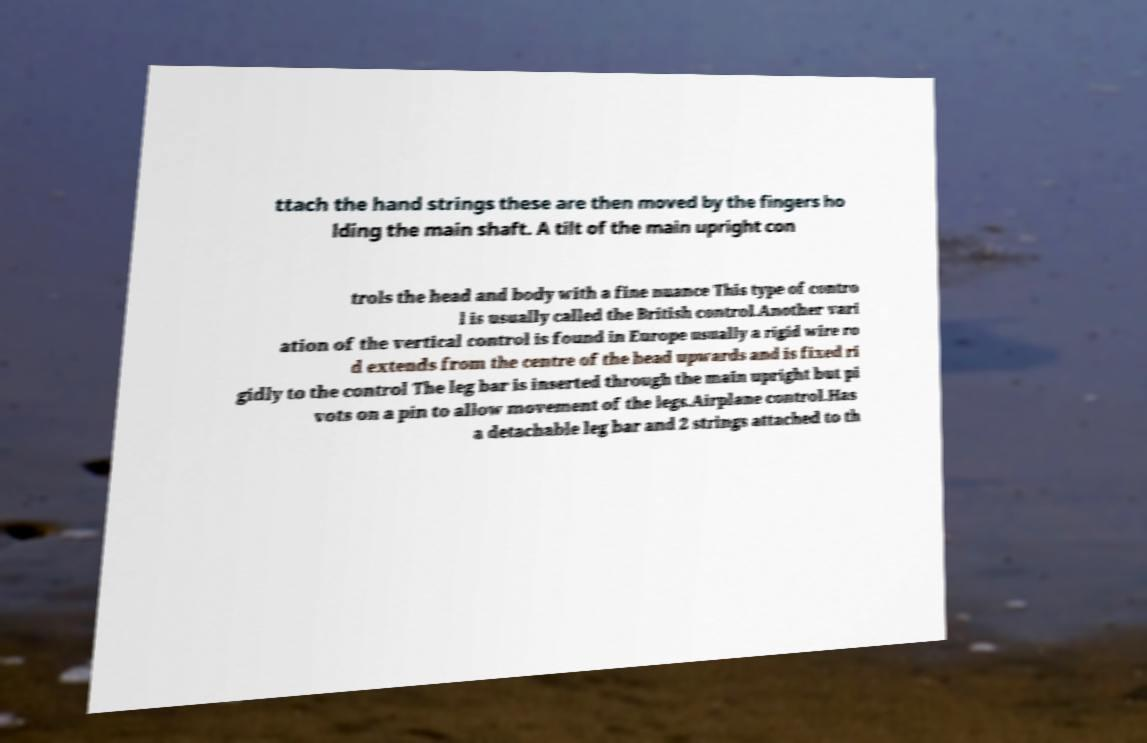Please identify and transcribe the text found in this image. ttach the hand strings these are then moved by the fingers ho lding the main shaft. A tilt of the main upright con trols the head and body with a fine nuance This type of contro l is usually called the British control.Another vari ation of the vertical control is found in Europe usually a rigid wire ro d extends from the centre of the head upwards and is fixed ri gidly to the control The leg bar is inserted through the main upright but pi vots on a pin to allow movement of the legs.Airplane control.Has a detachable leg bar and 2 strings attached to th 